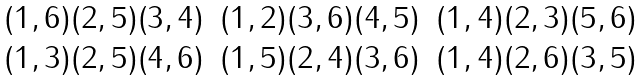Convert formula to latex. <formula><loc_0><loc_0><loc_500><loc_500>\begin{array} { c c c } ( 1 , 6 ) ( 2 , 5 ) ( 3 , 4 ) & ( 1 , 2 ) ( 3 , 6 ) ( 4 , 5 ) & ( 1 , 4 ) ( 2 , 3 ) ( 5 , 6 ) \\ ( 1 , 3 ) ( 2 , 5 ) ( 4 , 6 ) & ( 1 , 5 ) ( 2 , 4 ) ( 3 , 6 ) & ( 1 , 4 ) ( 2 , 6 ) ( 3 , 5 ) \end{array}</formula> 